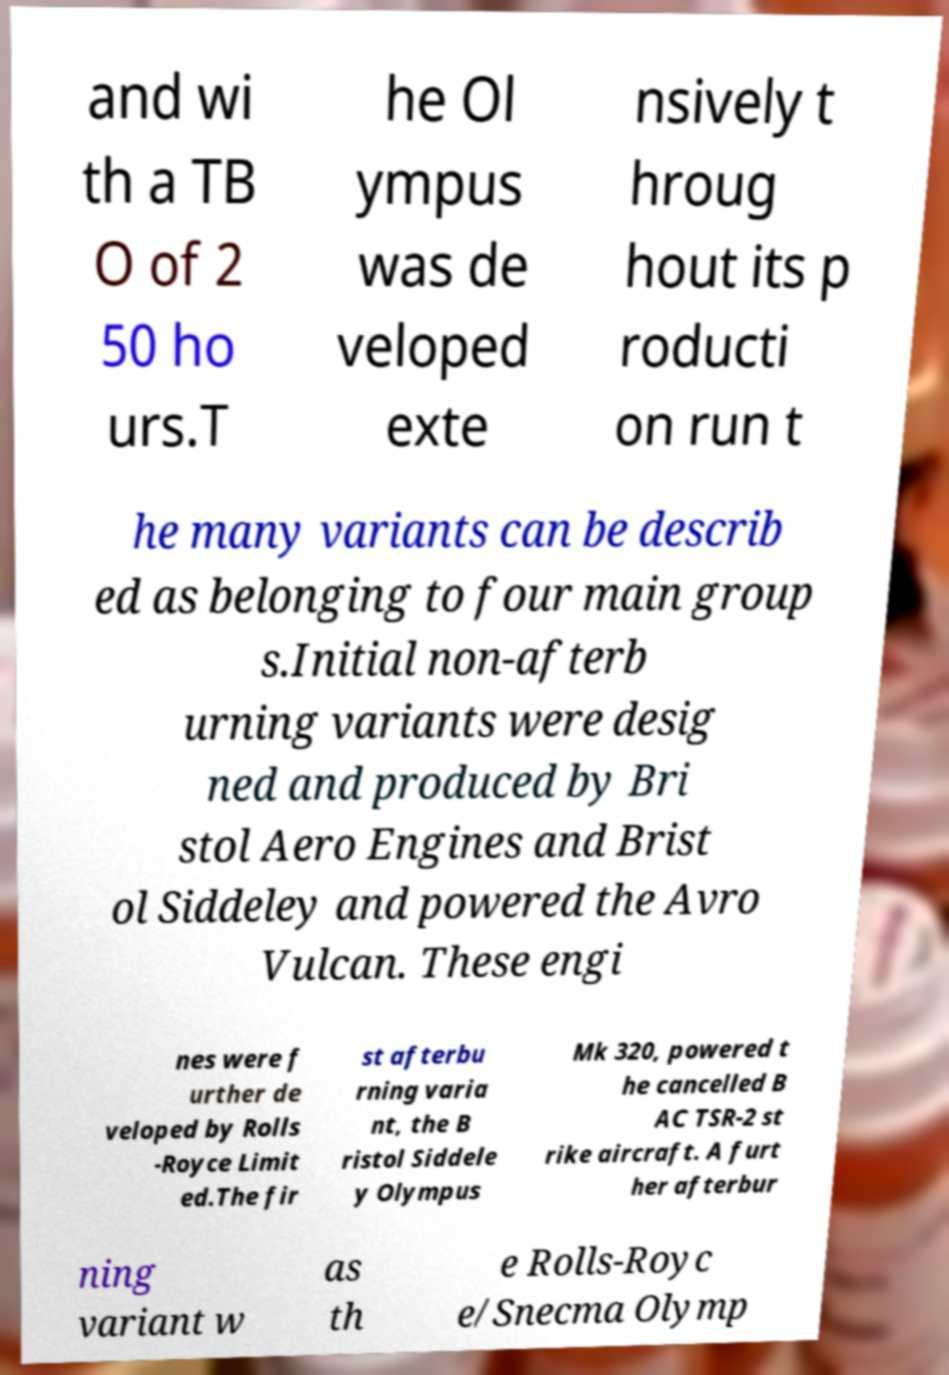Can you accurately transcribe the text from the provided image for me? and wi th a TB O of 2 50 ho urs.T he Ol ympus was de veloped exte nsively t hroug hout its p roducti on run t he many variants can be describ ed as belonging to four main group s.Initial non-afterb urning variants were desig ned and produced by Bri stol Aero Engines and Brist ol Siddeley and powered the Avro Vulcan. These engi nes were f urther de veloped by Rolls -Royce Limit ed.The fir st afterbu rning varia nt, the B ristol Siddele y Olympus Mk 320, powered t he cancelled B AC TSR-2 st rike aircraft. A furt her afterbur ning variant w as th e Rolls-Royc e/Snecma Olymp 